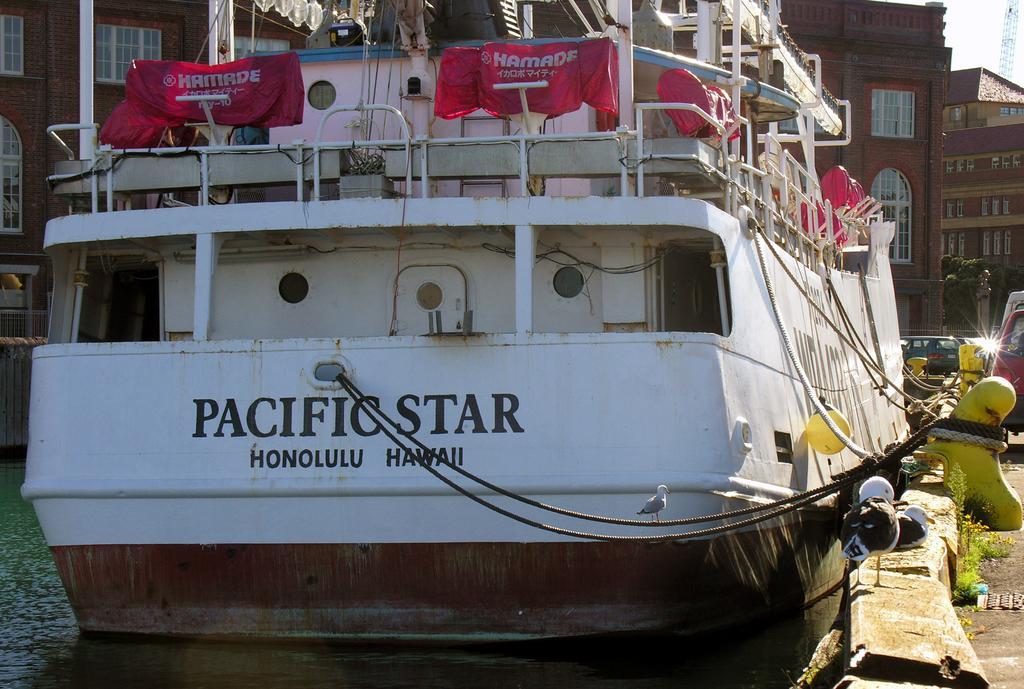Describe this image in one or two sentences. In front of the picture, we see a ship in white color. We see the sheets in red color with some text written on it. At the bottom, we see water and this water might be in the lake. Beside that, we see a yellow color object to which the ropes are tied. On the right side, we see the road and the grass. We see the cars are moving on the road. There are building in the background. In the right top, we see a tower and the sky. 